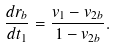<formula> <loc_0><loc_0><loc_500><loc_500>\frac { d r _ { b } } { d t _ { 1 } } = \frac { v _ { 1 } - v _ { 2 b } } { 1 - v _ { 2 b } } .</formula> 